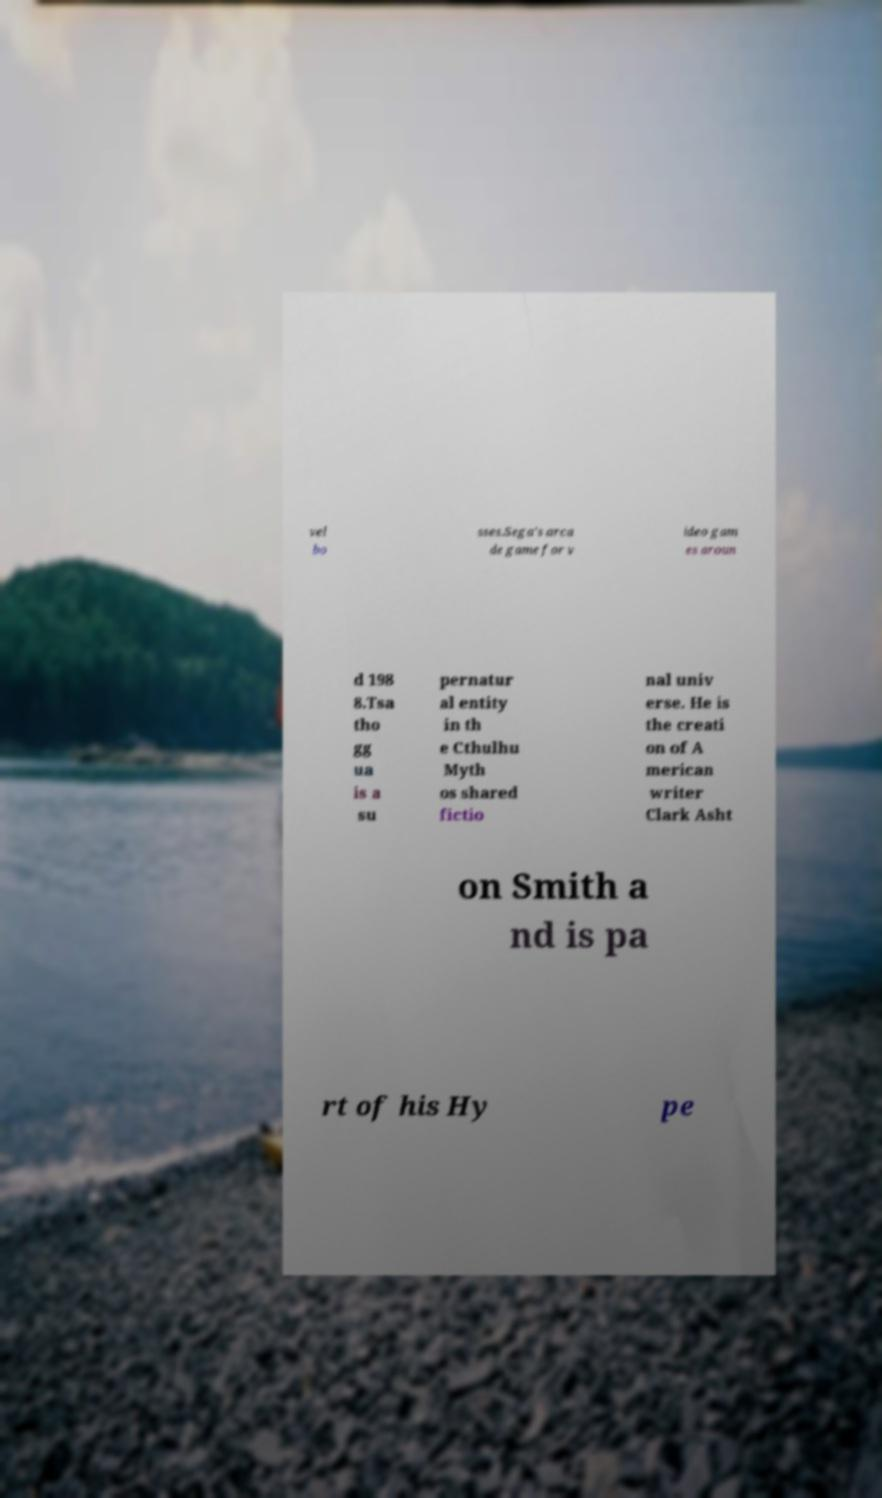I need the written content from this picture converted into text. Can you do that? vel bo sses.Sega's arca de game for v ideo gam es aroun d 198 8.Tsa tho gg ua is a su pernatur al entity in th e Cthulhu Myth os shared fictio nal univ erse. He is the creati on of A merican writer Clark Asht on Smith a nd is pa rt of his Hy pe 